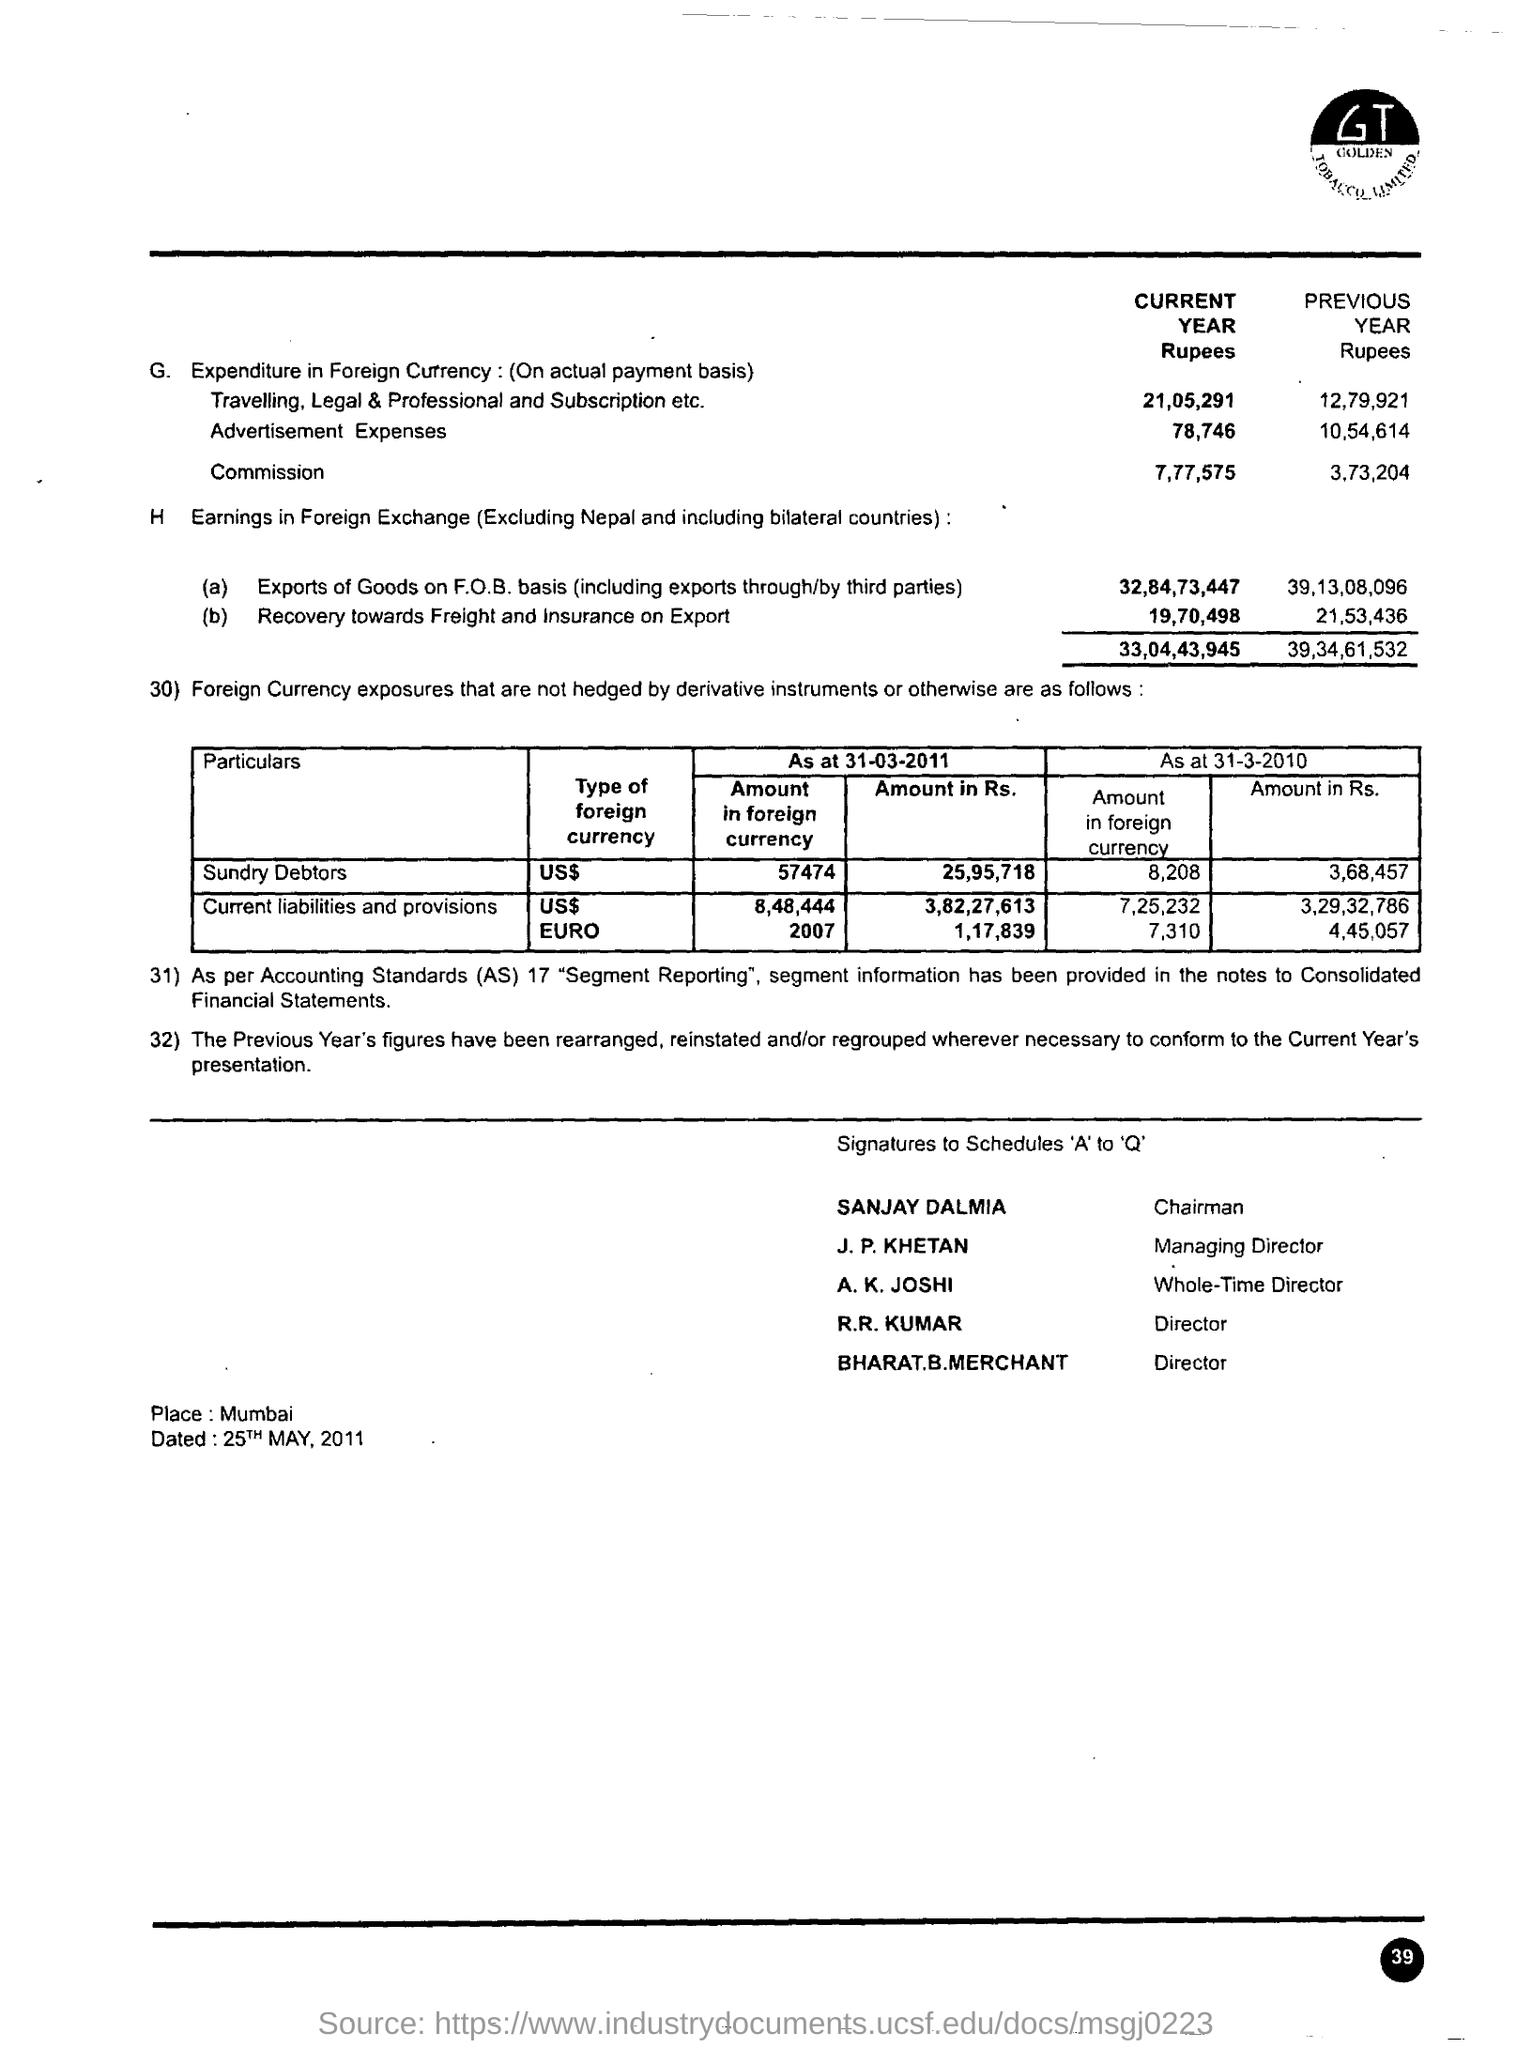Outline some significant characteristics in this image. GOLDEN TOBACCO LIMITED is the company whose name is mentioned. The document was dated 25th May, 2011. The commission for the current year is 7,77,575 rupees. Sanjay Dalmia is the chairman. 